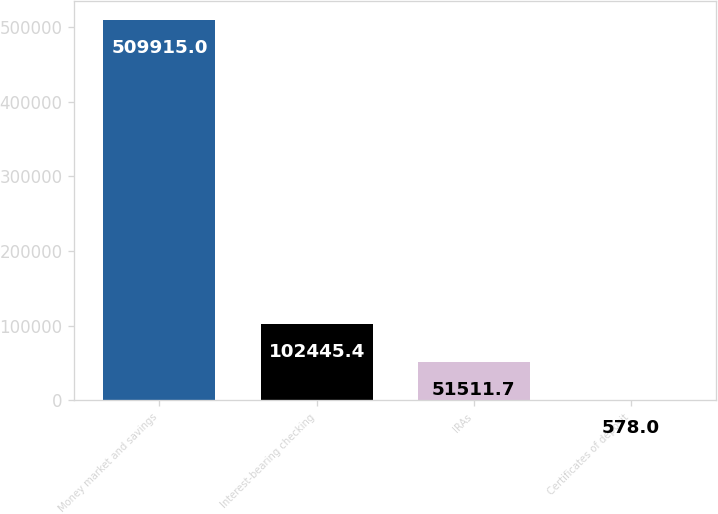<chart> <loc_0><loc_0><loc_500><loc_500><bar_chart><fcel>Money market and savings<fcel>Interest-bearing checking<fcel>IRAs<fcel>Certificates of deposit<nl><fcel>509915<fcel>102445<fcel>51511.7<fcel>578<nl></chart> 